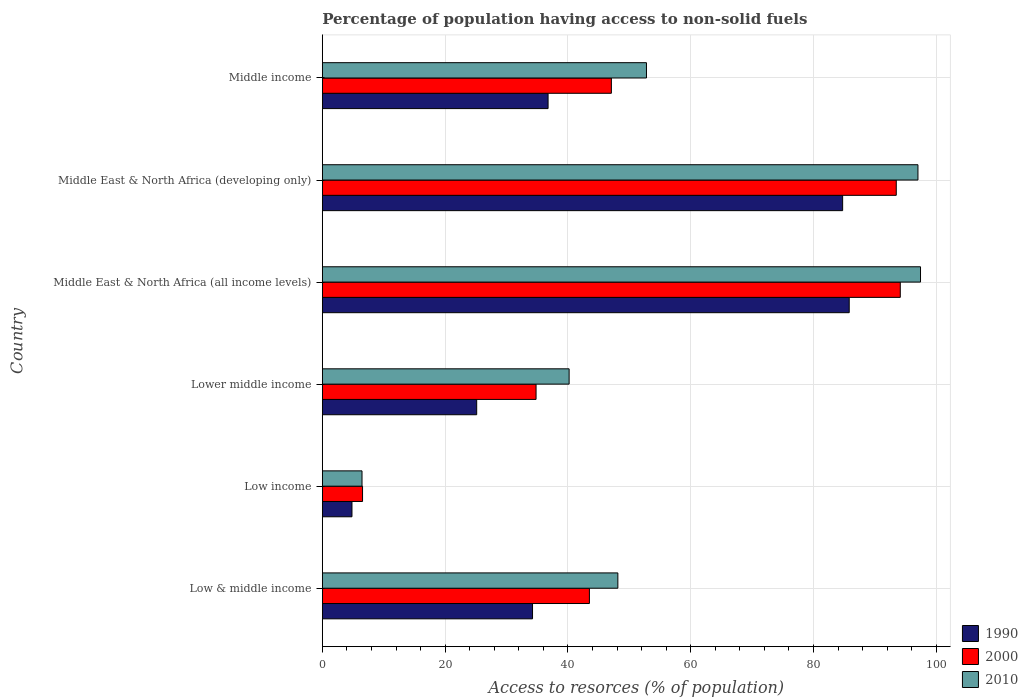How many different coloured bars are there?
Give a very brief answer. 3. Are the number of bars per tick equal to the number of legend labels?
Your answer should be compact. Yes. Are the number of bars on each tick of the Y-axis equal?
Your answer should be very brief. Yes. How many bars are there on the 5th tick from the top?
Provide a succinct answer. 3. What is the label of the 6th group of bars from the top?
Offer a terse response. Low & middle income. In how many cases, is the number of bars for a given country not equal to the number of legend labels?
Provide a short and direct response. 0. What is the percentage of population having access to non-solid fuels in 1990 in Middle East & North Africa (all income levels)?
Your answer should be very brief. 85.81. Across all countries, what is the maximum percentage of population having access to non-solid fuels in 2000?
Your answer should be very brief. 94.13. Across all countries, what is the minimum percentage of population having access to non-solid fuels in 2000?
Your answer should be very brief. 6.55. In which country was the percentage of population having access to non-solid fuels in 2010 maximum?
Keep it short and to the point. Middle East & North Africa (all income levels). In which country was the percentage of population having access to non-solid fuels in 2000 minimum?
Offer a very short reply. Low income. What is the total percentage of population having access to non-solid fuels in 2000 in the graph?
Provide a succinct answer. 319.54. What is the difference between the percentage of population having access to non-solid fuels in 1990 in Lower middle income and that in Middle East & North Africa (developing only)?
Give a very brief answer. -59.6. What is the difference between the percentage of population having access to non-solid fuels in 1990 in Middle income and the percentage of population having access to non-solid fuels in 2000 in Middle East & North Africa (all income levels)?
Offer a terse response. -57.36. What is the average percentage of population having access to non-solid fuels in 2010 per country?
Provide a short and direct response. 57. What is the difference between the percentage of population having access to non-solid fuels in 1990 and percentage of population having access to non-solid fuels in 2010 in Middle East & North Africa (developing only)?
Your answer should be compact. -12.27. In how many countries, is the percentage of population having access to non-solid fuels in 2010 greater than 28 %?
Your answer should be very brief. 5. What is the ratio of the percentage of population having access to non-solid fuels in 1990 in Lower middle income to that in Middle East & North Africa (all income levels)?
Your answer should be compact. 0.29. Is the percentage of population having access to non-solid fuels in 2010 in Low income less than that in Middle income?
Keep it short and to the point. Yes. What is the difference between the highest and the second highest percentage of population having access to non-solid fuels in 2000?
Give a very brief answer. 0.66. What is the difference between the highest and the lowest percentage of population having access to non-solid fuels in 1990?
Your response must be concise. 80.99. Is the sum of the percentage of population having access to non-solid fuels in 1990 in Middle East & North Africa (all income levels) and Middle income greater than the maximum percentage of population having access to non-solid fuels in 2000 across all countries?
Make the answer very short. Yes. Are all the bars in the graph horizontal?
Ensure brevity in your answer.  Yes. How many countries are there in the graph?
Offer a terse response. 6. Does the graph contain any zero values?
Provide a short and direct response. No. Does the graph contain grids?
Keep it short and to the point. Yes. How many legend labels are there?
Keep it short and to the point. 3. What is the title of the graph?
Your answer should be compact. Percentage of population having access to non-solid fuels. Does "1982" appear as one of the legend labels in the graph?
Provide a short and direct response. No. What is the label or title of the X-axis?
Provide a succinct answer. Access to resorces (% of population). What is the Access to resorces (% of population) of 1990 in Low & middle income?
Provide a short and direct response. 34.23. What is the Access to resorces (% of population) of 2000 in Low & middle income?
Offer a terse response. 43.5. What is the Access to resorces (% of population) of 2010 in Low & middle income?
Your answer should be compact. 48.13. What is the Access to resorces (% of population) in 1990 in Low income?
Ensure brevity in your answer.  4.83. What is the Access to resorces (% of population) of 2000 in Low income?
Your response must be concise. 6.55. What is the Access to resorces (% of population) of 2010 in Low income?
Offer a terse response. 6.46. What is the Access to resorces (% of population) in 1990 in Lower middle income?
Give a very brief answer. 25.14. What is the Access to resorces (% of population) in 2000 in Lower middle income?
Your answer should be very brief. 34.81. What is the Access to resorces (% of population) of 2010 in Lower middle income?
Your answer should be compact. 40.2. What is the Access to resorces (% of population) of 1990 in Middle East & North Africa (all income levels)?
Offer a very short reply. 85.81. What is the Access to resorces (% of population) in 2000 in Middle East & North Africa (all income levels)?
Make the answer very short. 94.13. What is the Access to resorces (% of population) of 2010 in Middle East & North Africa (all income levels)?
Provide a short and direct response. 97.43. What is the Access to resorces (% of population) in 1990 in Middle East & North Africa (developing only)?
Ensure brevity in your answer.  84.74. What is the Access to resorces (% of population) in 2000 in Middle East & North Africa (developing only)?
Provide a succinct answer. 93.48. What is the Access to resorces (% of population) of 2010 in Middle East & North Africa (developing only)?
Keep it short and to the point. 97.01. What is the Access to resorces (% of population) in 1990 in Middle income?
Provide a short and direct response. 36.77. What is the Access to resorces (% of population) of 2000 in Middle income?
Provide a short and direct response. 47.08. What is the Access to resorces (% of population) in 2010 in Middle income?
Keep it short and to the point. 52.79. Across all countries, what is the maximum Access to resorces (% of population) in 1990?
Provide a short and direct response. 85.81. Across all countries, what is the maximum Access to resorces (% of population) of 2000?
Your response must be concise. 94.13. Across all countries, what is the maximum Access to resorces (% of population) in 2010?
Give a very brief answer. 97.43. Across all countries, what is the minimum Access to resorces (% of population) in 1990?
Offer a very short reply. 4.83. Across all countries, what is the minimum Access to resorces (% of population) in 2000?
Offer a very short reply. 6.55. Across all countries, what is the minimum Access to resorces (% of population) in 2010?
Provide a short and direct response. 6.46. What is the total Access to resorces (% of population) in 1990 in the graph?
Your answer should be compact. 271.53. What is the total Access to resorces (% of population) in 2000 in the graph?
Make the answer very short. 319.54. What is the total Access to resorces (% of population) of 2010 in the graph?
Your answer should be compact. 342.02. What is the difference between the Access to resorces (% of population) of 1990 in Low & middle income and that in Low income?
Make the answer very short. 29.41. What is the difference between the Access to resorces (% of population) in 2000 in Low & middle income and that in Low income?
Your response must be concise. 36.95. What is the difference between the Access to resorces (% of population) of 2010 in Low & middle income and that in Low income?
Offer a very short reply. 41.67. What is the difference between the Access to resorces (% of population) of 1990 in Low & middle income and that in Lower middle income?
Offer a terse response. 9.09. What is the difference between the Access to resorces (% of population) of 2000 in Low & middle income and that in Lower middle income?
Your answer should be very brief. 8.69. What is the difference between the Access to resorces (% of population) in 2010 in Low & middle income and that in Lower middle income?
Ensure brevity in your answer.  7.94. What is the difference between the Access to resorces (% of population) of 1990 in Low & middle income and that in Middle East & North Africa (all income levels)?
Your response must be concise. -51.58. What is the difference between the Access to resorces (% of population) in 2000 in Low & middle income and that in Middle East & North Africa (all income levels)?
Your answer should be very brief. -50.63. What is the difference between the Access to resorces (% of population) in 2010 in Low & middle income and that in Middle East & North Africa (all income levels)?
Your answer should be compact. -49.29. What is the difference between the Access to resorces (% of population) of 1990 in Low & middle income and that in Middle East & North Africa (developing only)?
Offer a very short reply. -50.51. What is the difference between the Access to resorces (% of population) of 2000 in Low & middle income and that in Middle East & North Africa (developing only)?
Provide a succinct answer. -49.98. What is the difference between the Access to resorces (% of population) of 2010 in Low & middle income and that in Middle East & North Africa (developing only)?
Provide a short and direct response. -48.87. What is the difference between the Access to resorces (% of population) in 1990 in Low & middle income and that in Middle income?
Offer a terse response. -2.53. What is the difference between the Access to resorces (% of population) of 2000 in Low & middle income and that in Middle income?
Offer a very short reply. -3.58. What is the difference between the Access to resorces (% of population) in 2010 in Low & middle income and that in Middle income?
Keep it short and to the point. -4.66. What is the difference between the Access to resorces (% of population) in 1990 in Low income and that in Lower middle income?
Give a very brief answer. -20.31. What is the difference between the Access to resorces (% of population) in 2000 in Low income and that in Lower middle income?
Offer a terse response. -28.26. What is the difference between the Access to resorces (% of population) in 2010 in Low income and that in Lower middle income?
Offer a terse response. -33.73. What is the difference between the Access to resorces (% of population) in 1990 in Low income and that in Middle East & North Africa (all income levels)?
Make the answer very short. -80.99. What is the difference between the Access to resorces (% of population) of 2000 in Low income and that in Middle East & North Africa (all income levels)?
Your answer should be compact. -87.58. What is the difference between the Access to resorces (% of population) of 2010 in Low income and that in Middle East & North Africa (all income levels)?
Provide a succinct answer. -90.96. What is the difference between the Access to resorces (% of population) in 1990 in Low income and that in Middle East & North Africa (developing only)?
Provide a short and direct response. -79.91. What is the difference between the Access to resorces (% of population) of 2000 in Low income and that in Middle East & North Africa (developing only)?
Provide a short and direct response. -86.93. What is the difference between the Access to resorces (% of population) in 2010 in Low income and that in Middle East & North Africa (developing only)?
Your answer should be compact. -90.54. What is the difference between the Access to resorces (% of population) in 1990 in Low income and that in Middle income?
Ensure brevity in your answer.  -31.94. What is the difference between the Access to resorces (% of population) in 2000 in Low income and that in Middle income?
Provide a succinct answer. -40.53. What is the difference between the Access to resorces (% of population) of 2010 in Low income and that in Middle income?
Provide a short and direct response. -46.33. What is the difference between the Access to resorces (% of population) in 1990 in Lower middle income and that in Middle East & North Africa (all income levels)?
Offer a very short reply. -60.67. What is the difference between the Access to resorces (% of population) in 2000 in Lower middle income and that in Middle East & North Africa (all income levels)?
Your response must be concise. -59.32. What is the difference between the Access to resorces (% of population) of 2010 in Lower middle income and that in Middle East & North Africa (all income levels)?
Ensure brevity in your answer.  -57.23. What is the difference between the Access to resorces (% of population) in 1990 in Lower middle income and that in Middle East & North Africa (developing only)?
Keep it short and to the point. -59.6. What is the difference between the Access to resorces (% of population) of 2000 in Lower middle income and that in Middle East & North Africa (developing only)?
Your answer should be compact. -58.66. What is the difference between the Access to resorces (% of population) in 2010 in Lower middle income and that in Middle East & North Africa (developing only)?
Offer a very short reply. -56.81. What is the difference between the Access to resorces (% of population) in 1990 in Lower middle income and that in Middle income?
Your answer should be very brief. -11.63. What is the difference between the Access to resorces (% of population) in 2000 in Lower middle income and that in Middle income?
Ensure brevity in your answer.  -12.26. What is the difference between the Access to resorces (% of population) of 2010 in Lower middle income and that in Middle income?
Ensure brevity in your answer.  -12.6. What is the difference between the Access to resorces (% of population) of 1990 in Middle East & North Africa (all income levels) and that in Middle East & North Africa (developing only)?
Your response must be concise. 1.07. What is the difference between the Access to resorces (% of population) in 2000 in Middle East & North Africa (all income levels) and that in Middle East & North Africa (developing only)?
Your answer should be compact. 0.66. What is the difference between the Access to resorces (% of population) in 2010 in Middle East & North Africa (all income levels) and that in Middle East & North Africa (developing only)?
Keep it short and to the point. 0.42. What is the difference between the Access to resorces (% of population) in 1990 in Middle East & North Africa (all income levels) and that in Middle income?
Keep it short and to the point. 49.05. What is the difference between the Access to resorces (% of population) of 2000 in Middle East & North Africa (all income levels) and that in Middle income?
Ensure brevity in your answer.  47.06. What is the difference between the Access to resorces (% of population) in 2010 in Middle East & North Africa (all income levels) and that in Middle income?
Keep it short and to the point. 44.63. What is the difference between the Access to resorces (% of population) of 1990 in Middle East & North Africa (developing only) and that in Middle income?
Keep it short and to the point. 47.97. What is the difference between the Access to resorces (% of population) of 2000 in Middle East & North Africa (developing only) and that in Middle income?
Your response must be concise. 46.4. What is the difference between the Access to resorces (% of population) of 2010 in Middle East & North Africa (developing only) and that in Middle income?
Give a very brief answer. 44.21. What is the difference between the Access to resorces (% of population) of 1990 in Low & middle income and the Access to resorces (% of population) of 2000 in Low income?
Offer a very short reply. 27.68. What is the difference between the Access to resorces (% of population) of 1990 in Low & middle income and the Access to resorces (% of population) of 2010 in Low income?
Make the answer very short. 27.77. What is the difference between the Access to resorces (% of population) of 2000 in Low & middle income and the Access to resorces (% of population) of 2010 in Low income?
Offer a very short reply. 37.04. What is the difference between the Access to resorces (% of population) of 1990 in Low & middle income and the Access to resorces (% of population) of 2000 in Lower middle income?
Ensure brevity in your answer.  -0.58. What is the difference between the Access to resorces (% of population) of 1990 in Low & middle income and the Access to resorces (% of population) of 2010 in Lower middle income?
Your answer should be very brief. -5.96. What is the difference between the Access to resorces (% of population) of 2000 in Low & middle income and the Access to resorces (% of population) of 2010 in Lower middle income?
Provide a short and direct response. 3.3. What is the difference between the Access to resorces (% of population) in 1990 in Low & middle income and the Access to resorces (% of population) in 2000 in Middle East & North Africa (all income levels)?
Ensure brevity in your answer.  -59.9. What is the difference between the Access to resorces (% of population) in 1990 in Low & middle income and the Access to resorces (% of population) in 2010 in Middle East & North Africa (all income levels)?
Offer a terse response. -63.19. What is the difference between the Access to resorces (% of population) of 2000 in Low & middle income and the Access to resorces (% of population) of 2010 in Middle East & North Africa (all income levels)?
Your answer should be very brief. -53.93. What is the difference between the Access to resorces (% of population) in 1990 in Low & middle income and the Access to resorces (% of population) in 2000 in Middle East & North Africa (developing only)?
Your answer should be very brief. -59.24. What is the difference between the Access to resorces (% of population) of 1990 in Low & middle income and the Access to resorces (% of population) of 2010 in Middle East & North Africa (developing only)?
Your response must be concise. -62.77. What is the difference between the Access to resorces (% of population) of 2000 in Low & middle income and the Access to resorces (% of population) of 2010 in Middle East & North Africa (developing only)?
Provide a short and direct response. -53.51. What is the difference between the Access to resorces (% of population) in 1990 in Low & middle income and the Access to resorces (% of population) in 2000 in Middle income?
Ensure brevity in your answer.  -12.84. What is the difference between the Access to resorces (% of population) of 1990 in Low & middle income and the Access to resorces (% of population) of 2010 in Middle income?
Your answer should be very brief. -18.56. What is the difference between the Access to resorces (% of population) of 2000 in Low & middle income and the Access to resorces (% of population) of 2010 in Middle income?
Your answer should be compact. -9.29. What is the difference between the Access to resorces (% of population) in 1990 in Low income and the Access to resorces (% of population) in 2000 in Lower middle income?
Provide a short and direct response. -29.98. What is the difference between the Access to resorces (% of population) in 1990 in Low income and the Access to resorces (% of population) in 2010 in Lower middle income?
Make the answer very short. -35.37. What is the difference between the Access to resorces (% of population) of 2000 in Low income and the Access to resorces (% of population) of 2010 in Lower middle income?
Your answer should be compact. -33.65. What is the difference between the Access to resorces (% of population) in 1990 in Low income and the Access to resorces (% of population) in 2000 in Middle East & North Africa (all income levels)?
Your answer should be compact. -89.3. What is the difference between the Access to resorces (% of population) in 1990 in Low income and the Access to resorces (% of population) in 2010 in Middle East & North Africa (all income levels)?
Ensure brevity in your answer.  -92.6. What is the difference between the Access to resorces (% of population) in 2000 in Low income and the Access to resorces (% of population) in 2010 in Middle East & North Africa (all income levels)?
Keep it short and to the point. -90.88. What is the difference between the Access to resorces (% of population) of 1990 in Low income and the Access to resorces (% of population) of 2000 in Middle East & North Africa (developing only)?
Provide a succinct answer. -88.65. What is the difference between the Access to resorces (% of population) in 1990 in Low income and the Access to resorces (% of population) in 2010 in Middle East & North Africa (developing only)?
Provide a short and direct response. -92.18. What is the difference between the Access to resorces (% of population) in 2000 in Low income and the Access to resorces (% of population) in 2010 in Middle East & North Africa (developing only)?
Keep it short and to the point. -90.46. What is the difference between the Access to resorces (% of population) in 1990 in Low income and the Access to resorces (% of population) in 2000 in Middle income?
Your answer should be compact. -42.25. What is the difference between the Access to resorces (% of population) in 1990 in Low income and the Access to resorces (% of population) in 2010 in Middle income?
Offer a very short reply. -47.96. What is the difference between the Access to resorces (% of population) of 2000 in Low income and the Access to resorces (% of population) of 2010 in Middle income?
Make the answer very short. -46.24. What is the difference between the Access to resorces (% of population) in 1990 in Lower middle income and the Access to resorces (% of population) in 2000 in Middle East & North Africa (all income levels)?
Offer a very short reply. -68.99. What is the difference between the Access to resorces (% of population) in 1990 in Lower middle income and the Access to resorces (% of population) in 2010 in Middle East & North Africa (all income levels)?
Offer a very short reply. -72.29. What is the difference between the Access to resorces (% of population) of 2000 in Lower middle income and the Access to resorces (% of population) of 2010 in Middle East & North Africa (all income levels)?
Ensure brevity in your answer.  -62.62. What is the difference between the Access to resorces (% of population) in 1990 in Lower middle income and the Access to resorces (% of population) in 2000 in Middle East & North Africa (developing only)?
Ensure brevity in your answer.  -68.34. What is the difference between the Access to resorces (% of population) of 1990 in Lower middle income and the Access to resorces (% of population) of 2010 in Middle East & North Africa (developing only)?
Keep it short and to the point. -71.87. What is the difference between the Access to resorces (% of population) of 2000 in Lower middle income and the Access to resorces (% of population) of 2010 in Middle East & North Africa (developing only)?
Make the answer very short. -62.2. What is the difference between the Access to resorces (% of population) of 1990 in Lower middle income and the Access to resorces (% of population) of 2000 in Middle income?
Provide a succinct answer. -21.94. What is the difference between the Access to resorces (% of population) of 1990 in Lower middle income and the Access to resorces (% of population) of 2010 in Middle income?
Provide a succinct answer. -27.65. What is the difference between the Access to resorces (% of population) in 2000 in Lower middle income and the Access to resorces (% of population) in 2010 in Middle income?
Your response must be concise. -17.98. What is the difference between the Access to resorces (% of population) in 1990 in Middle East & North Africa (all income levels) and the Access to resorces (% of population) in 2000 in Middle East & North Africa (developing only)?
Offer a very short reply. -7.66. What is the difference between the Access to resorces (% of population) of 1990 in Middle East & North Africa (all income levels) and the Access to resorces (% of population) of 2010 in Middle East & North Africa (developing only)?
Make the answer very short. -11.19. What is the difference between the Access to resorces (% of population) of 2000 in Middle East & North Africa (all income levels) and the Access to resorces (% of population) of 2010 in Middle East & North Africa (developing only)?
Your answer should be compact. -2.88. What is the difference between the Access to resorces (% of population) in 1990 in Middle East & North Africa (all income levels) and the Access to resorces (% of population) in 2000 in Middle income?
Make the answer very short. 38.74. What is the difference between the Access to resorces (% of population) in 1990 in Middle East & North Africa (all income levels) and the Access to resorces (% of population) in 2010 in Middle income?
Keep it short and to the point. 33.02. What is the difference between the Access to resorces (% of population) of 2000 in Middle East & North Africa (all income levels) and the Access to resorces (% of population) of 2010 in Middle income?
Your answer should be very brief. 41.34. What is the difference between the Access to resorces (% of population) in 1990 in Middle East & North Africa (developing only) and the Access to resorces (% of population) in 2000 in Middle income?
Provide a short and direct response. 37.67. What is the difference between the Access to resorces (% of population) in 1990 in Middle East & North Africa (developing only) and the Access to resorces (% of population) in 2010 in Middle income?
Ensure brevity in your answer.  31.95. What is the difference between the Access to resorces (% of population) of 2000 in Middle East & North Africa (developing only) and the Access to resorces (% of population) of 2010 in Middle income?
Your answer should be very brief. 40.68. What is the average Access to resorces (% of population) in 1990 per country?
Your answer should be compact. 45.25. What is the average Access to resorces (% of population) in 2000 per country?
Provide a succinct answer. 53.26. What is the average Access to resorces (% of population) in 2010 per country?
Provide a short and direct response. 57. What is the difference between the Access to resorces (% of population) of 1990 and Access to resorces (% of population) of 2000 in Low & middle income?
Your answer should be compact. -9.26. What is the difference between the Access to resorces (% of population) of 1990 and Access to resorces (% of population) of 2010 in Low & middle income?
Provide a succinct answer. -13.9. What is the difference between the Access to resorces (% of population) of 2000 and Access to resorces (% of population) of 2010 in Low & middle income?
Make the answer very short. -4.63. What is the difference between the Access to resorces (% of population) in 1990 and Access to resorces (% of population) in 2000 in Low income?
Your answer should be very brief. -1.72. What is the difference between the Access to resorces (% of population) of 1990 and Access to resorces (% of population) of 2010 in Low income?
Offer a very short reply. -1.64. What is the difference between the Access to resorces (% of population) in 2000 and Access to resorces (% of population) in 2010 in Low income?
Your answer should be compact. 0.09. What is the difference between the Access to resorces (% of population) in 1990 and Access to resorces (% of population) in 2000 in Lower middle income?
Provide a short and direct response. -9.67. What is the difference between the Access to resorces (% of population) of 1990 and Access to resorces (% of population) of 2010 in Lower middle income?
Provide a short and direct response. -15.06. What is the difference between the Access to resorces (% of population) in 2000 and Access to resorces (% of population) in 2010 in Lower middle income?
Make the answer very short. -5.39. What is the difference between the Access to resorces (% of population) in 1990 and Access to resorces (% of population) in 2000 in Middle East & North Africa (all income levels)?
Your answer should be very brief. -8.32. What is the difference between the Access to resorces (% of population) in 1990 and Access to resorces (% of population) in 2010 in Middle East & North Africa (all income levels)?
Your answer should be very brief. -11.61. What is the difference between the Access to resorces (% of population) of 2000 and Access to resorces (% of population) of 2010 in Middle East & North Africa (all income levels)?
Provide a short and direct response. -3.3. What is the difference between the Access to resorces (% of population) of 1990 and Access to resorces (% of population) of 2000 in Middle East & North Africa (developing only)?
Ensure brevity in your answer.  -8.73. What is the difference between the Access to resorces (% of population) of 1990 and Access to resorces (% of population) of 2010 in Middle East & North Africa (developing only)?
Keep it short and to the point. -12.27. What is the difference between the Access to resorces (% of population) in 2000 and Access to resorces (% of population) in 2010 in Middle East & North Africa (developing only)?
Make the answer very short. -3.53. What is the difference between the Access to resorces (% of population) in 1990 and Access to resorces (% of population) in 2000 in Middle income?
Provide a succinct answer. -10.31. What is the difference between the Access to resorces (% of population) in 1990 and Access to resorces (% of population) in 2010 in Middle income?
Keep it short and to the point. -16.03. What is the difference between the Access to resorces (% of population) in 2000 and Access to resorces (% of population) in 2010 in Middle income?
Offer a terse response. -5.72. What is the ratio of the Access to resorces (% of population) in 1990 in Low & middle income to that in Low income?
Make the answer very short. 7.09. What is the ratio of the Access to resorces (% of population) of 2000 in Low & middle income to that in Low income?
Keep it short and to the point. 6.64. What is the ratio of the Access to resorces (% of population) in 2010 in Low & middle income to that in Low income?
Your answer should be compact. 7.45. What is the ratio of the Access to resorces (% of population) of 1990 in Low & middle income to that in Lower middle income?
Your answer should be very brief. 1.36. What is the ratio of the Access to resorces (% of population) of 2000 in Low & middle income to that in Lower middle income?
Offer a terse response. 1.25. What is the ratio of the Access to resorces (% of population) of 2010 in Low & middle income to that in Lower middle income?
Ensure brevity in your answer.  1.2. What is the ratio of the Access to resorces (% of population) of 1990 in Low & middle income to that in Middle East & North Africa (all income levels)?
Your answer should be compact. 0.4. What is the ratio of the Access to resorces (% of population) in 2000 in Low & middle income to that in Middle East & North Africa (all income levels)?
Offer a terse response. 0.46. What is the ratio of the Access to resorces (% of population) in 2010 in Low & middle income to that in Middle East & North Africa (all income levels)?
Provide a short and direct response. 0.49. What is the ratio of the Access to resorces (% of population) of 1990 in Low & middle income to that in Middle East & North Africa (developing only)?
Make the answer very short. 0.4. What is the ratio of the Access to resorces (% of population) in 2000 in Low & middle income to that in Middle East & North Africa (developing only)?
Make the answer very short. 0.47. What is the ratio of the Access to resorces (% of population) of 2010 in Low & middle income to that in Middle East & North Africa (developing only)?
Provide a succinct answer. 0.5. What is the ratio of the Access to resorces (% of population) of 1990 in Low & middle income to that in Middle income?
Provide a short and direct response. 0.93. What is the ratio of the Access to resorces (% of population) in 2000 in Low & middle income to that in Middle income?
Your answer should be very brief. 0.92. What is the ratio of the Access to resorces (% of population) of 2010 in Low & middle income to that in Middle income?
Offer a very short reply. 0.91. What is the ratio of the Access to resorces (% of population) in 1990 in Low income to that in Lower middle income?
Provide a succinct answer. 0.19. What is the ratio of the Access to resorces (% of population) in 2000 in Low income to that in Lower middle income?
Give a very brief answer. 0.19. What is the ratio of the Access to resorces (% of population) of 2010 in Low income to that in Lower middle income?
Provide a short and direct response. 0.16. What is the ratio of the Access to resorces (% of population) in 1990 in Low income to that in Middle East & North Africa (all income levels)?
Your answer should be compact. 0.06. What is the ratio of the Access to resorces (% of population) of 2000 in Low income to that in Middle East & North Africa (all income levels)?
Provide a short and direct response. 0.07. What is the ratio of the Access to resorces (% of population) in 2010 in Low income to that in Middle East & North Africa (all income levels)?
Offer a very short reply. 0.07. What is the ratio of the Access to resorces (% of population) of 1990 in Low income to that in Middle East & North Africa (developing only)?
Provide a succinct answer. 0.06. What is the ratio of the Access to resorces (% of population) in 2000 in Low income to that in Middle East & North Africa (developing only)?
Your response must be concise. 0.07. What is the ratio of the Access to resorces (% of population) in 2010 in Low income to that in Middle East & North Africa (developing only)?
Keep it short and to the point. 0.07. What is the ratio of the Access to resorces (% of population) of 1990 in Low income to that in Middle income?
Keep it short and to the point. 0.13. What is the ratio of the Access to resorces (% of population) in 2000 in Low income to that in Middle income?
Offer a very short reply. 0.14. What is the ratio of the Access to resorces (% of population) of 2010 in Low income to that in Middle income?
Offer a terse response. 0.12. What is the ratio of the Access to resorces (% of population) in 1990 in Lower middle income to that in Middle East & North Africa (all income levels)?
Your answer should be very brief. 0.29. What is the ratio of the Access to resorces (% of population) in 2000 in Lower middle income to that in Middle East & North Africa (all income levels)?
Your answer should be compact. 0.37. What is the ratio of the Access to resorces (% of population) of 2010 in Lower middle income to that in Middle East & North Africa (all income levels)?
Your response must be concise. 0.41. What is the ratio of the Access to resorces (% of population) of 1990 in Lower middle income to that in Middle East & North Africa (developing only)?
Your response must be concise. 0.3. What is the ratio of the Access to resorces (% of population) of 2000 in Lower middle income to that in Middle East & North Africa (developing only)?
Provide a succinct answer. 0.37. What is the ratio of the Access to resorces (% of population) of 2010 in Lower middle income to that in Middle East & North Africa (developing only)?
Offer a very short reply. 0.41. What is the ratio of the Access to resorces (% of population) of 1990 in Lower middle income to that in Middle income?
Offer a terse response. 0.68. What is the ratio of the Access to resorces (% of population) of 2000 in Lower middle income to that in Middle income?
Ensure brevity in your answer.  0.74. What is the ratio of the Access to resorces (% of population) of 2010 in Lower middle income to that in Middle income?
Give a very brief answer. 0.76. What is the ratio of the Access to resorces (% of population) in 1990 in Middle East & North Africa (all income levels) to that in Middle East & North Africa (developing only)?
Offer a very short reply. 1.01. What is the ratio of the Access to resorces (% of population) in 2010 in Middle East & North Africa (all income levels) to that in Middle East & North Africa (developing only)?
Keep it short and to the point. 1. What is the ratio of the Access to resorces (% of population) of 1990 in Middle East & North Africa (all income levels) to that in Middle income?
Give a very brief answer. 2.33. What is the ratio of the Access to resorces (% of population) of 2000 in Middle East & North Africa (all income levels) to that in Middle income?
Make the answer very short. 2. What is the ratio of the Access to resorces (% of population) in 2010 in Middle East & North Africa (all income levels) to that in Middle income?
Keep it short and to the point. 1.85. What is the ratio of the Access to resorces (% of population) of 1990 in Middle East & North Africa (developing only) to that in Middle income?
Your answer should be compact. 2.3. What is the ratio of the Access to resorces (% of population) of 2000 in Middle East & North Africa (developing only) to that in Middle income?
Provide a short and direct response. 1.99. What is the ratio of the Access to resorces (% of population) in 2010 in Middle East & North Africa (developing only) to that in Middle income?
Offer a very short reply. 1.84. What is the difference between the highest and the second highest Access to resorces (% of population) in 1990?
Provide a short and direct response. 1.07. What is the difference between the highest and the second highest Access to resorces (% of population) in 2000?
Keep it short and to the point. 0.66. What is the difference between the highest and the second highest Access to resorces (% of population) in 2010?
Offer a terse response. 0.42. What is the difference between the highest and the lowest Access to resorces (% of population) of 1990?
Give a very brief answer. 80.99. What is the difference between the highest and the lowest Access to resorces (% of population) in 2000?
Your answer should be very brief. 87.58. What is the difference between the highest and the lowest Access to resorces (% of population) in 2010?
Your answer should be compact. 90.96. 